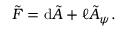<formula> <loc_0><loc_0><loc_500><loc_500>\tilde { F } = d \tilde { A } + \ell \tilde { A } _ { \psi } .</formula> 